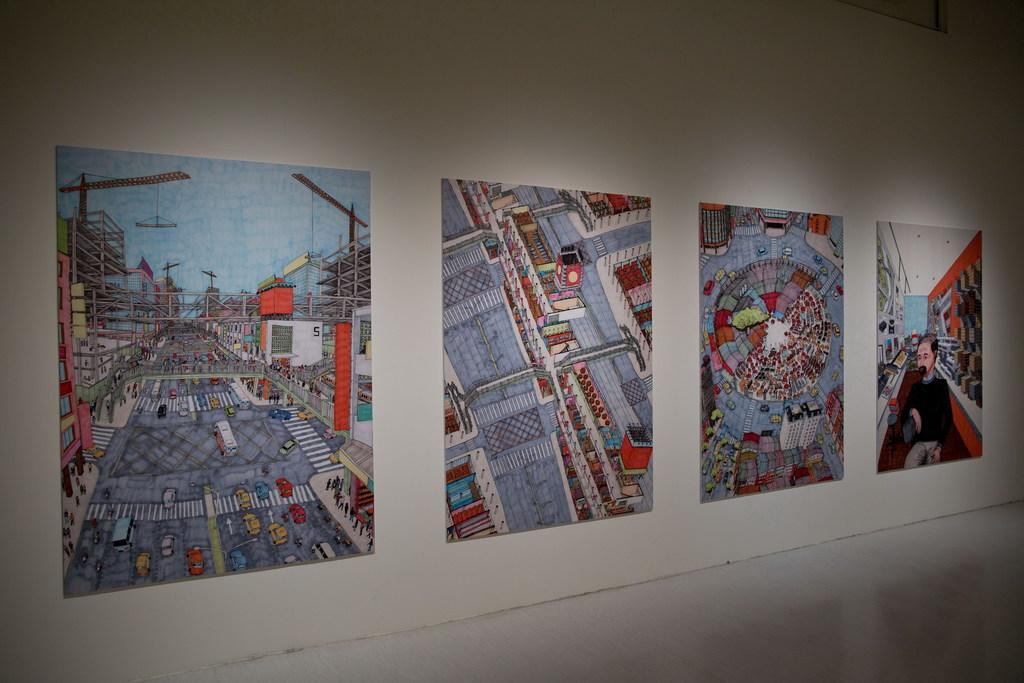How would you summarize this image in a sentence or two? In this image I can see few posts on this wall. 